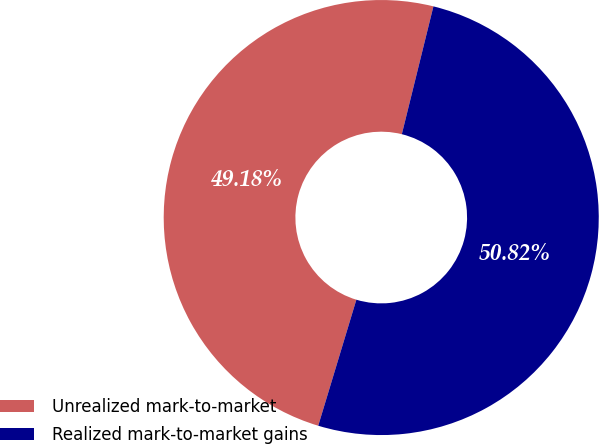Convert chart. <chart><loc_0><loc_0><loc_500><loc_500><pie_chart><fcel>Unrealized mark-to-market<fcel>Realized mark-to-market gains<nl><fcel>49.18%<fcel>50.82%<nl></chart> 